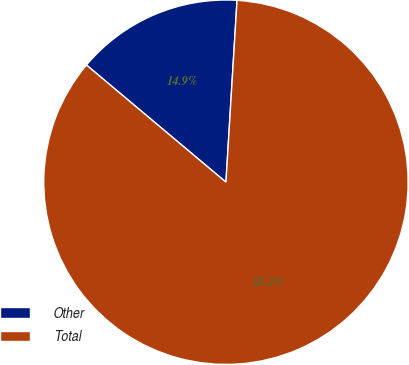Convert chart to OTSL. <chart><loc_0><loc_0><loc_500><loc_500><pie_chart><fcel>Other<fcel>Total<nl><fcel>14.85%<fcel>85.15%<nl></chart> 